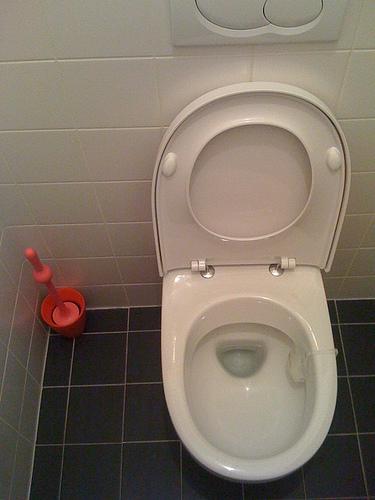How many toilets are in the picture?
Answer briefly. 1. What color is the floor?
Answer briefly. Gray. Is the toilet clean?
Answer briefly. Yes. What color is the toilet brush?
Quick response, please. Pink. Does the tile need to be regrouted?
Concise answer only. No. Who was the last person to use this toilet, a man or a woman?
Write a very short answer. Man. 